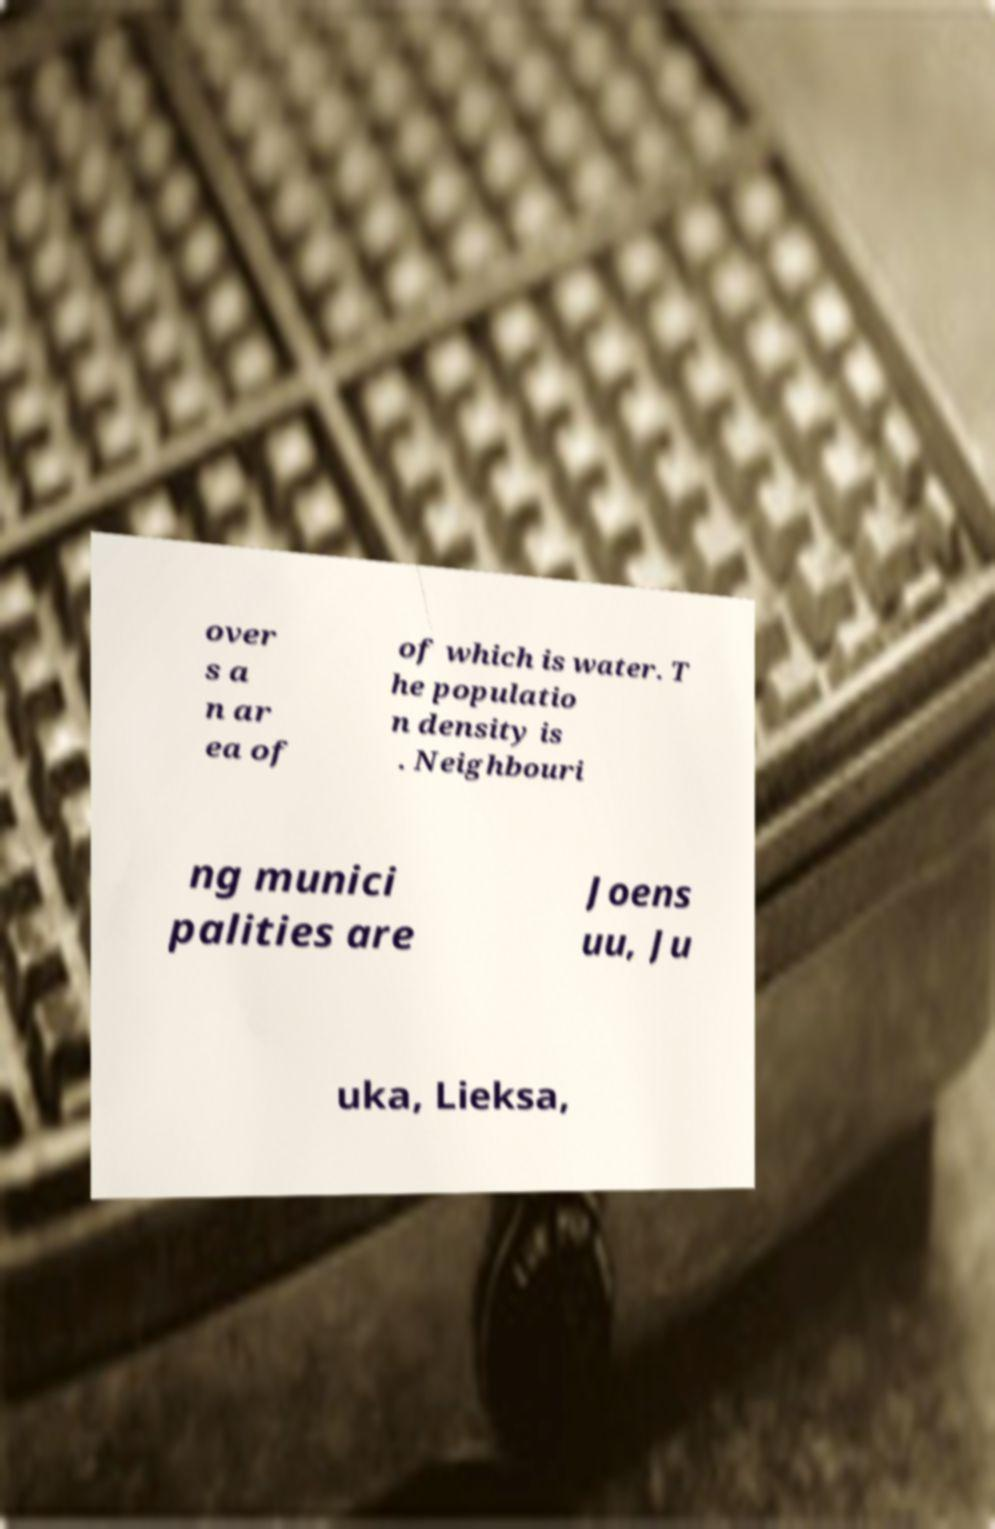Can you read and provide the text displayed in the image?This photo seems to have some interesting text. Can you extract and type it out for me? over s a n ar ea of of which is water. T he populatio n density is . Neighbouri ng munici palities are Joens uu, Ju uka, Lieksa, 